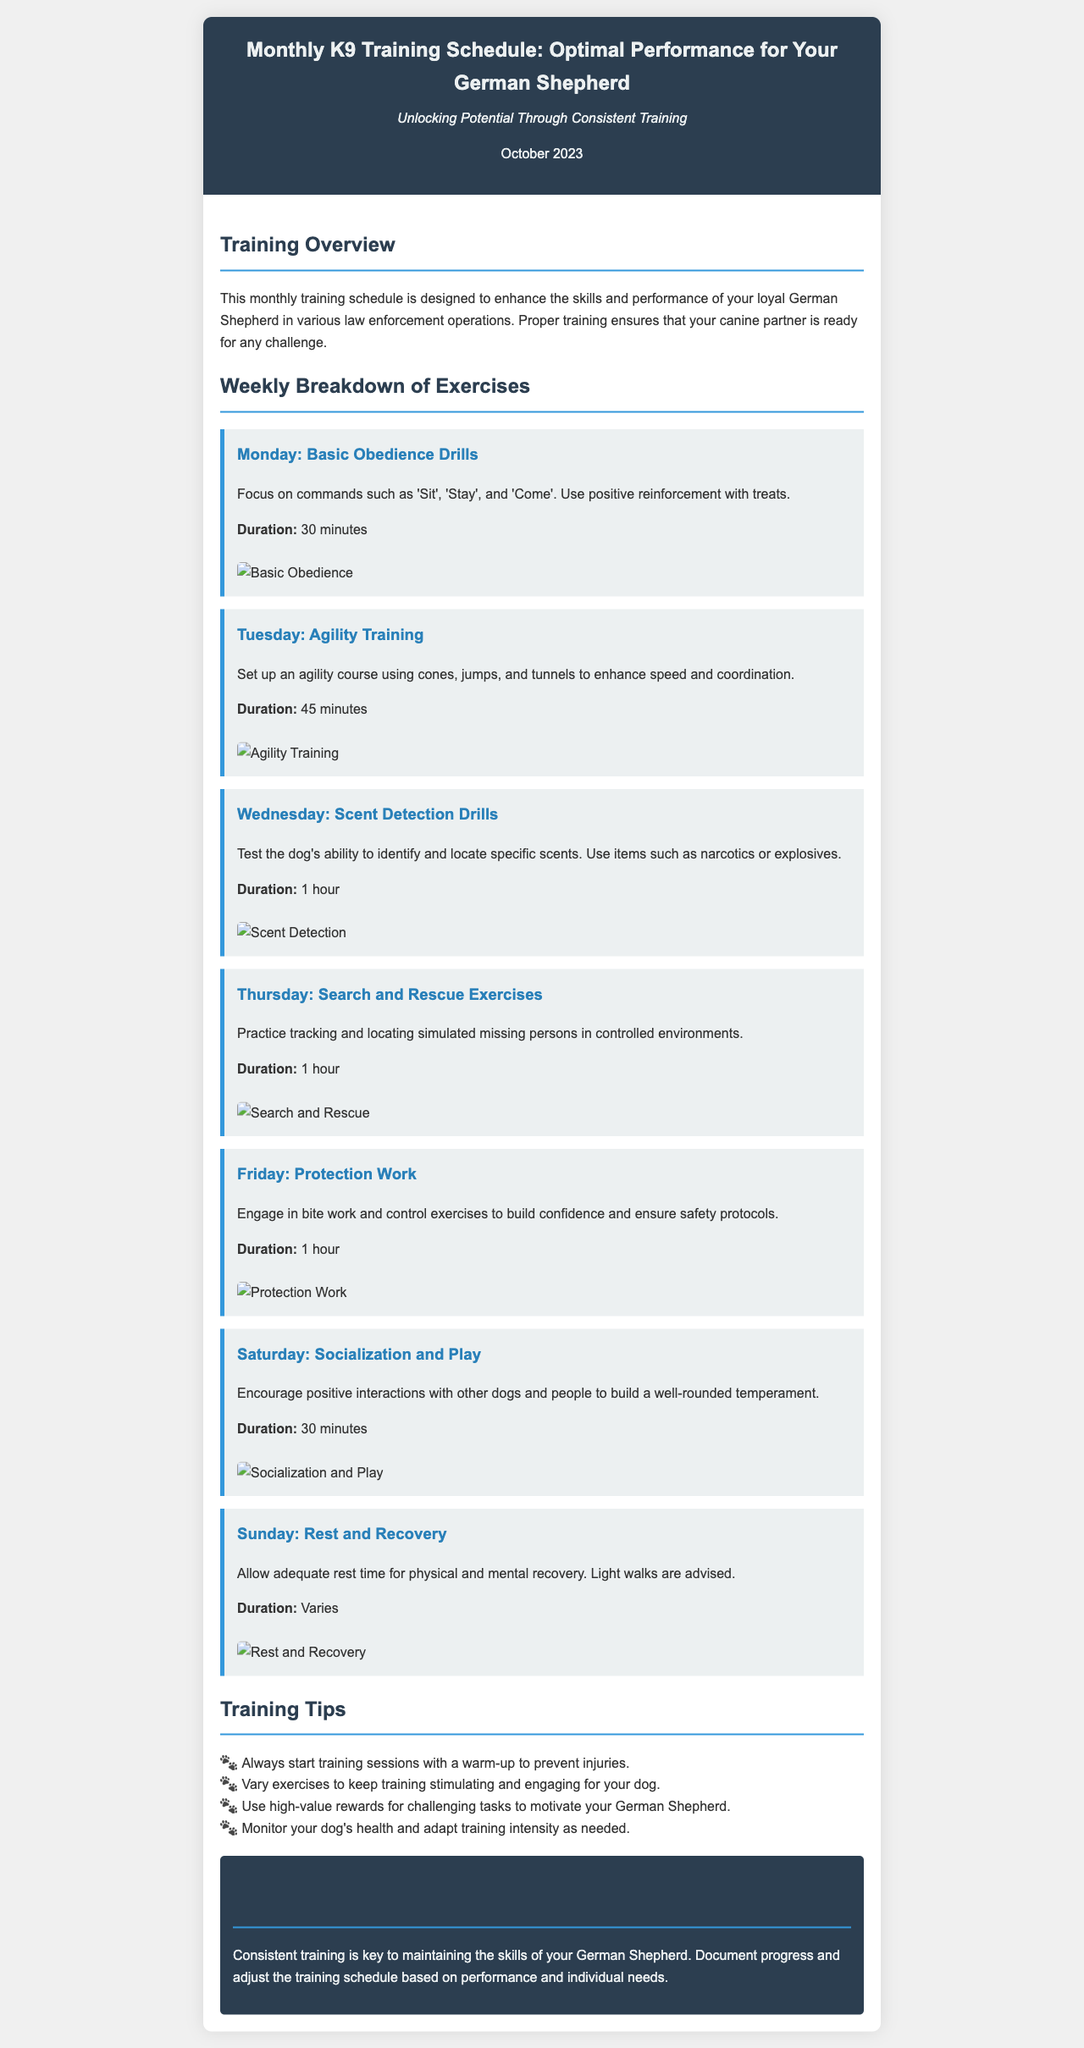What is the title of the newsletter? The title of the newsletter is presented prominently at the top of the document.
Answer: Monthly K9 Training Schedule: Optimal Performance for Your German Shepherd How long is the training session for Scent Detection Drills? The duration for Scent Detection Drills is specified in the exercise section of the document.
Answer: 1 hour What exercise is scheduled for Tuesday? Each day has a specific exercise listed in the weekly breakdown.
Answer: Agility Training What is emphasized during the Basic Obedience Drills? The content outlines key commands to focus on during this exercise.
Answer: 'Sit', 'Stay', and 'Come' How many training tips are provided in the Tips section? The count of tips is found in the bulleted list within the document.
Answer: 4 What type of training occurs on Saturday? Each day's focus is specified, with Saturday dedicated to a specific activity.
Answer: Socialization and Play What is the overall conclusion about training consistency? The conclusion summarizes the importance of training based on the skills of the dog.
Answer: Key to maintaining skills What is the average duration of the training sessions listed? The document states the duration for each day, allowing for calculations of average.
Answer: Approximately 45 minutes (averaged from provided durations) 